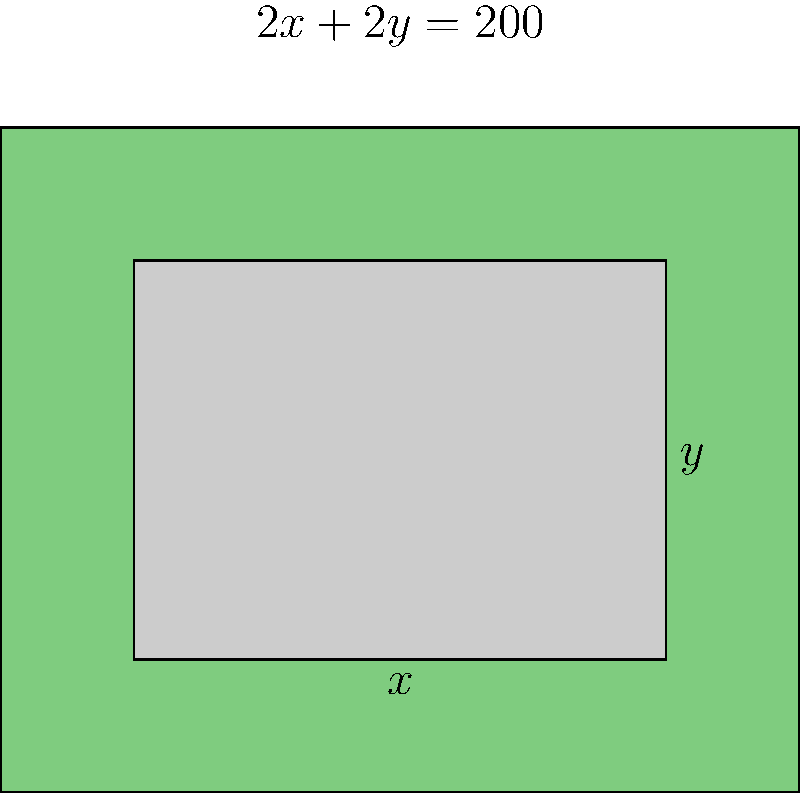As a real estate developer in Seoul, you're planning a rectangular apartment complex. The local zoning laws require the perimeter of the complex to be exactly 200 meters. If $x$ represents the width and $y$ represents the length of the complex, what dimensions will maximize the floor area of the apartment complex? Let's approach this step-by-step:

1) First, we need to express the area of the complex in terms of $x$ and $y$:
   Area $A = xy$

2) We're given that the perimeter is 200 meters. This can be expressed as:
   $2x + 2y = 200$

3) We can solve this for $y$:
   $y = 100 - x$

4) Now we can express the area solely in terms of $x$:
   $A = x(100-x) = 100x - x^2$

5) To find the maximum value of $A$, we need to find where its derivative equals zero:
   $\frac{dA}{dx} = 100 - 2x$

6) Setting this equal to zero:
   $100 - 2x = 0$
   $2x = 100$
   $x = 50$

7) Since the second derivative $\frac{d^2A}{dx^2} = -2$ is negative, this critical point is a maximum.

8) If $x = 50$, then $y = 100 - 50 = 50$ as well.

Therefore, the dimensions that maximize the floor area are 50 meters by 50 meters.
Answer: 50 m × 50 m 